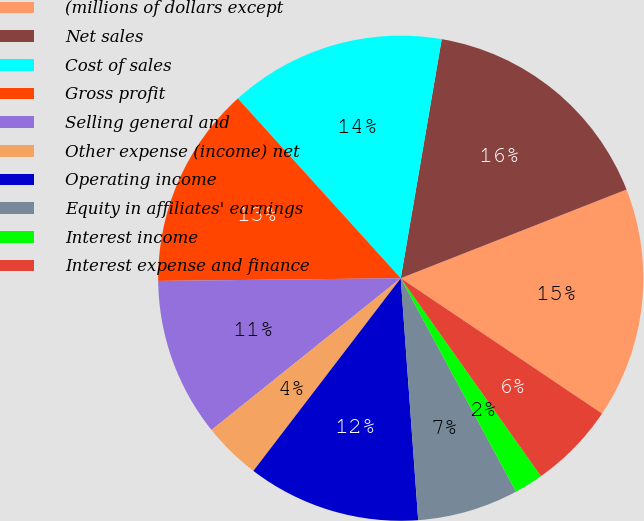Convert chart. <chart><loc_0><loc_0><loc_500><loc_500><pie_chart><fcel>(millions of dollars except<fcel>Net sales<fcel>Cost of sales<fcel>Gross profit<fcel>Selling general and<fcel>Other expense (income) net<fcel>Operating income<fcel>Equity in affiliates' earnings<fcel>Interest income<fcel>Interest expense and finance<nl><fcel>15.38%<fcel>16.34%<fcel>14.42%<fcel>13.46%<fcel>10.58%<fcel>3.85%<fcel>11.54%<fcel>6.73%<fcel>1.93%<fcel>5.77%<nl></chart> 